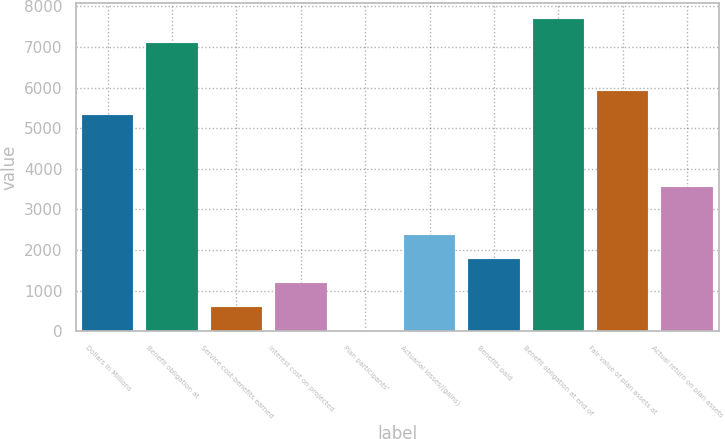Convert chart to OTSL. <chart><loc_0><loc_0><loc_500><loc_500><bar_chart><fcel>Dollars in Millions<fcel>Benefit obligation at<fcel>Service cost-benefits earned<fcel>Interest cost on projected<fcel>Plan participants'<fcel>Actuarial losses/(gains)<fcel>Benefits paid<fcel>Benefit obligation at end of<fcel>Fair value of plan assets at<fcel>Actual return on plan assets<nl><fcel>5326.5<fcel>7101<fcel>594.5<fcel>1186<fcel>3<fcel>2369<fcel>1777.5<fcel>7692.5<fcel>5918<fcel>3552<nl></chart> 